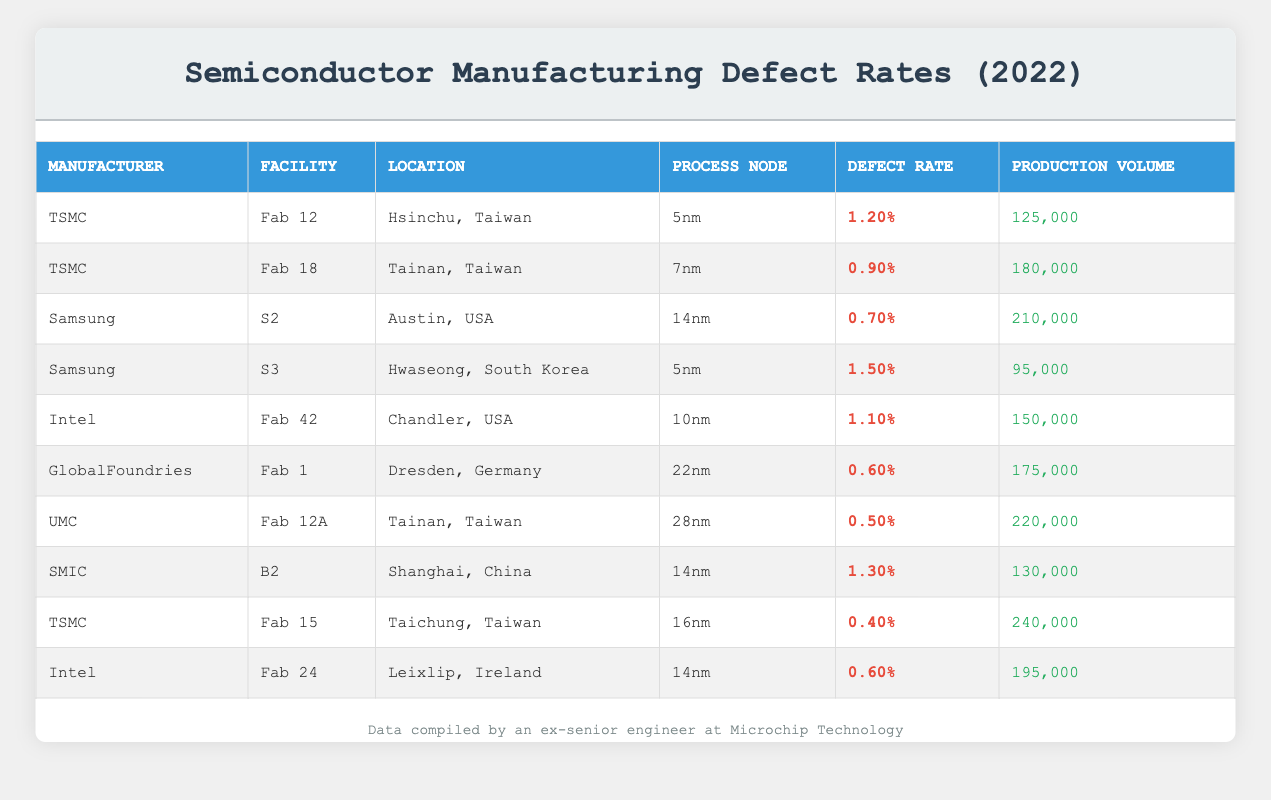What is the highest defect rate among the listed manufacturers? To find the highest defect rate, we can look through each manufacturer's defect rate in the table. The rates are: TSMC (1.20%, 0.90%), Samsung (0.70%, 1.50%), Intel (1.10%, 0.60%), GlobalFoundries (0.60%), UMC (0.50%), and SMIC (1.30%). Comparing these values, the highest defect rate is 1.50% from Samsung's S3 facility.
Answer: 1.50% Which manufacturer has the lowest production volume? By reviewing the production volume column, we can see the values: TSMC (125000, 180000, 240000), Samsung (210000, 95000), Intel (150000, 195000), GlobalFoundries (175000), UMC (220000), and SMIC (130000). The lowest production volume is 95000 from Samsung's S3 facility.
Answer: 95000 What is the average defect rate for Intel facilities? Intel has two facilities listed: Fab 42 with a defect rate of 1.10% and Fab 24 with a defect rate of 0.60%. To find the average defect rate, we add these two rates (1.10% + 0.60% = 1.70%) and then divide by the number of facilities (2). The average is therefore 1.70% / 2 = 0.85%.
Answer: 0.85% Is the defect rate of TSMC's Fab 15 lower than that of GlobalFoundries' Fab 1? TSMC's Fab 15 has a defect rate of 0.40%, while GlobalFoundries' Fab 1 has a defect rate of 0.60%. Since 0.40% is less than 0.60%, it confirms that TSMC's Fab 15 does indeed have a lower defect rate.
Answer: Yes What is the total production volume of all facilities using the 14nm process node? The facilities using a 14nm process node are Samsung's S2 (210000), SMIC's B2 (130000), and Intel's Fab 24 (195000). We add these production volumes: 210000 + 130000 + 195000 = 535000.
Answer: 535000 Which facility has the highest production volume and what is that volume? By looking at the production volume values, TSMC's Fab 15 has the highest value of 240000. Checking all entries confirms that this is indeed the maximum.
Answer: 240000 How many manufacturers have a defect rate below 1%? Checking the defect rates, we find that UMC (0.50%), GlobalFoundries (0.60%), and TSMC's Fab 15 (0.40%) all have defect rates below 1%. Counting these gives us a total of 3 manufacturers.
Answer: 3 Which process node has the maximum defect rate? From the defect rates considering each process node: 5nm (1.20%, 1.50%), 7nm (0.90%), 10nm (1.10%), 14nm (0.70%, 1.30%), 16nm (0.40%), 22nm (0.60%), 28nm (0.50%). The 5nm process node has the maximum defect rate at 1.50% from Samsung's S3 facility.
Answer: 5nm What is the defect rate difference between TSMC's Fab 18 and Intel's Fab 42? TSMC's Fab 18 has a defect rate of 0.90% and Intel's Fab 42 has a defect rate of 1.10%. To find the difference, we subtract (1.10% - 0.90% = 0.20%). Hence, the difference is 0.20%.
Answer: 0.20% 